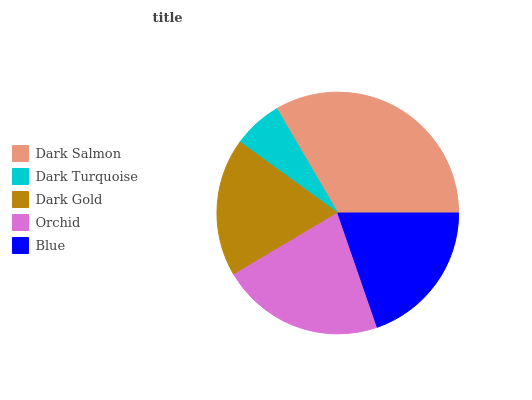Is Dark Turquoise the minimum?
Answer yes or no. Yes. Is Dark Salmon the maximum?
Answer yes or no. Yes. Is Dark Gold the minimum?
Answer yes or no. No. Is Dark Gold the maximum?
Answer yes or no. No. Is Dark Gold greater than Dark Turquoise?
Answer yes or no. Yes. Is Dark Turquoise less than Dark Gold?
Answer yes or no. Yes. Is Dark Turquoise greater than Dark Gold?
Answer yes or no. No. Is Dark Gold less than Dark Turquoise?
Answer yes or no. No. Is Blue the high median?
Answer yes or no. Yes. Is Blue the low median?
Answer yes or no. Yes. Is Dark Turquoise the high median?
Answer yes or no. No. Is Dark Salmon the low median?
Answer yes or no. No. 